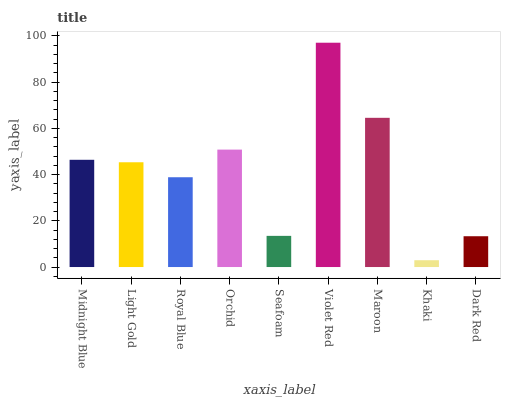Is Light Gold the minimum?
Answer yes or no. No. Is Light Gold the maximum?
Answer yes or no. No. Is Midnight Blue greater than Light Gold?
Answer yes or no. Yes. Is Light Gold less than Midnight Blue?
Answer yes or no. Yes. Is Light Gold greater than Midnight Blue?
Answer yes or no. No. Is Midnight Blue less than Light Gold?
Answer yes or no. No. Is Light Gold the high median?
Answer yes or no. Yes. Is Light Gold the low median?
Answer yes or no. Yes. Is Seafoam the high median?
Answer yes or no. No. Is Midnight Blue the low median?
Answer yes or no. No. 